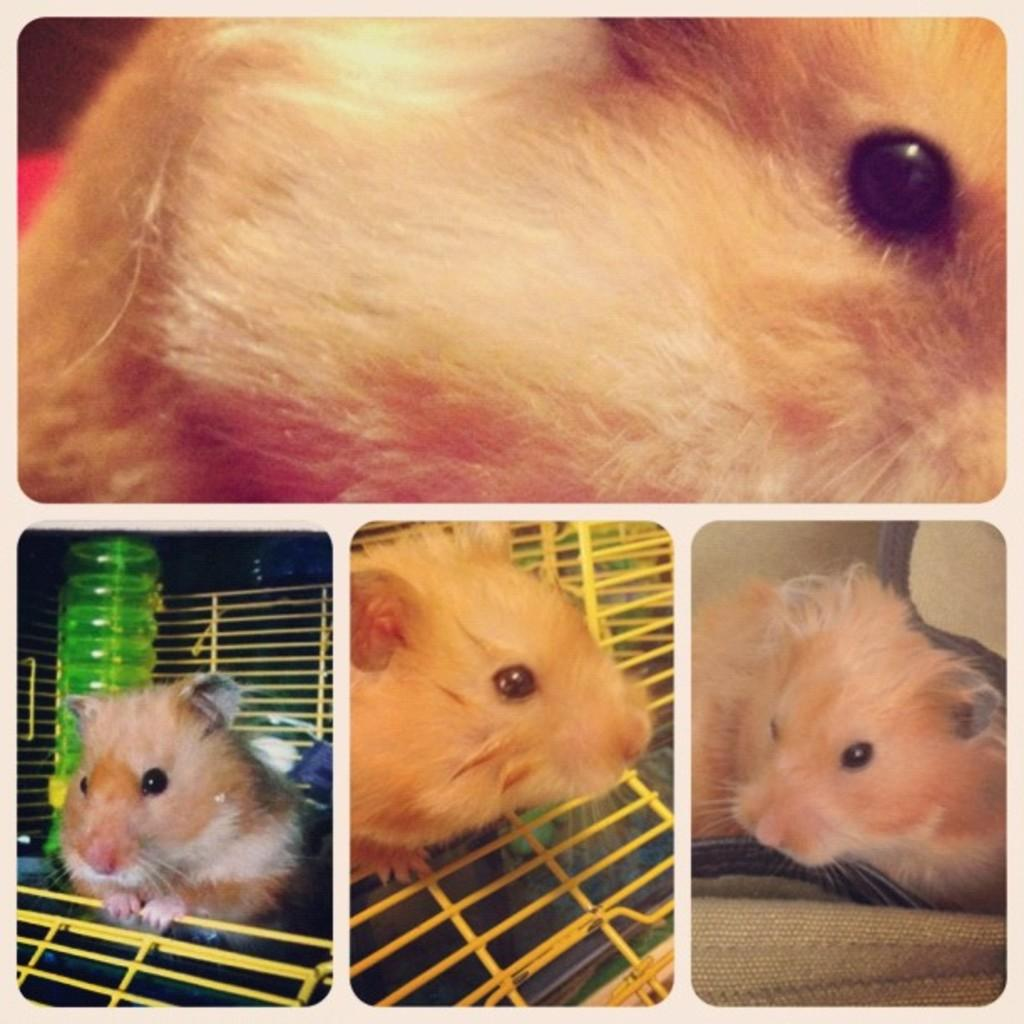How many pictures are included in the collage? The collage has four pictures. Can you describe one of the pictures in the collage? One of the pictures features a guinea pig in a cage. What type of tooth can be seen in the picture with the guinea pig? There are no teeth visible in the picture with the guinea pig, as guinea pigs do not have teeth like humans. 